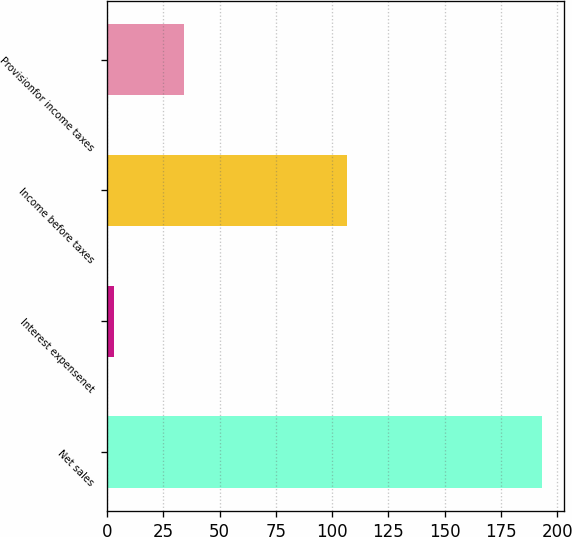Convert chart to OTSL. <chart><loc_0><loc_0><loc_500><loc_500><bar_chart><fcel>Net sales<fcel>Interest expensenet<fcel>Income before taxes<fcel>Provisionfor income taxes<nl><fcel>193.4<fcel>3.1<fcel>106.7<fcel>34.3<nl></chart> 